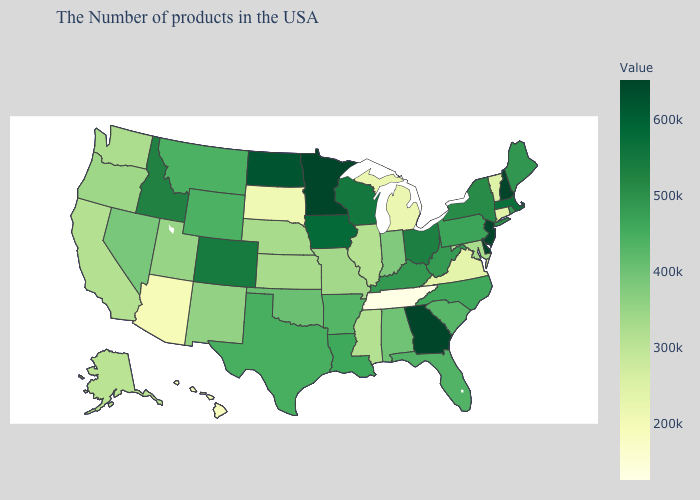Which states have the lowest value in the USA?
Answer briefly. Tennessee. Does Virginia have the lowest value in the USA?
Short answer required. No. Which states hav the highest value in the West?
Short answer required. Colorado. Which states have the lowest value in the MidWest?
Write a very short answer. South Dakota. 